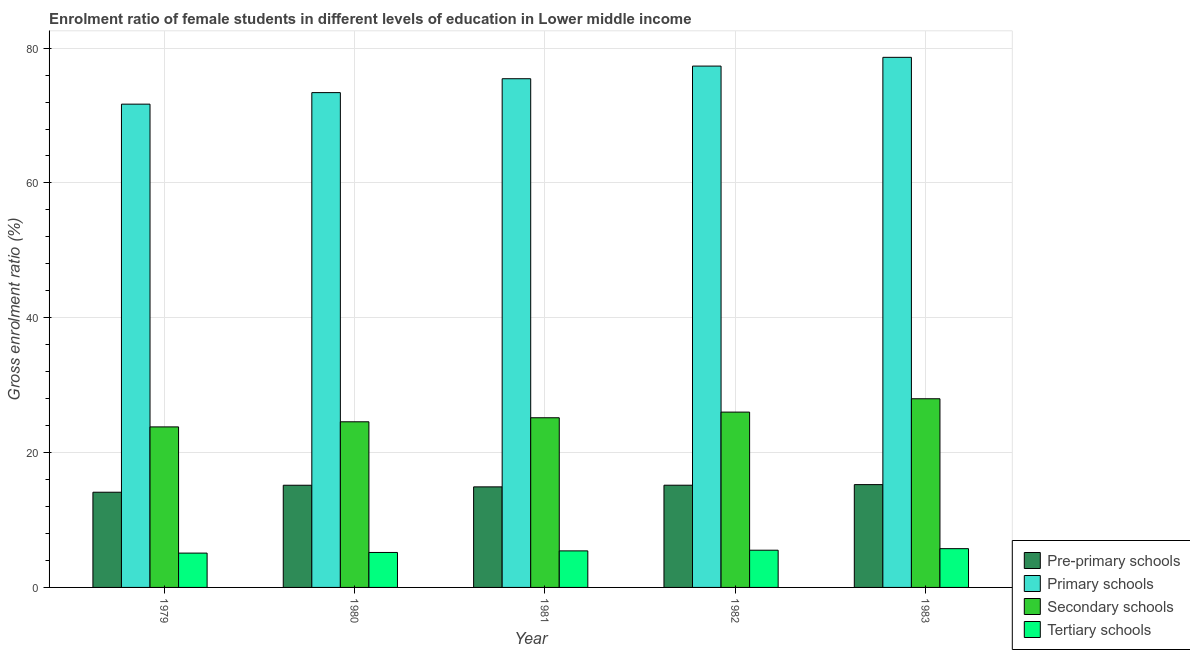Are the number of bars on each tick of the X-axis equal?
Offer a very short reply. Yes. How many bars are there on the 1st tick from the left?
Give a very brief answer. 4. How many bars are there on the 5th tick from the right?
Your answer should be very brief. 4. What is the label of the 1st group of bars from the left?
Give a very brief answer. 1979. What is the gross enrolment ratio(male) in tertiary schools in 1981?
Provide a short and direct response. 5.42. Across all years, what is the maximum gross enrolment ratio(male) in pre-primary schools?
Offer a terse response. 15.25. Across all years, what is the minimum gross enrolment ratio(male) in tertiary schools?
Ensure brevity in your answer.  5.09. In which year was the gross enrolment ratio(male) in pre-primary schools minimum?
Give a very brief answer. 1979. What is the total gross enrolment ratio(male) in pre-primary schools in the graph?
Keep it short and to the point. 74.61. What is the difference between the gross enrolment ratio(male) in pre-primary schools in 1979 and that in 1982?
Make the answer very short. -1.04. What is the difference between the gross enrolment ratio(male) in pre-primary schools in 1979 and the gross enrolment ratio(male) in tertiary schools in 1981?
Your answer should be compact. -0.79. What is the average gross enrolment ratio(male) in secondary schools per year?
Provide a succinct answer. 25.51. In how many years, is the gross enrolment ratio(male) in secondary schools greater than 56 %?
Keep it short and to the point. 0. What is the ratio of the gross enrolment ratio(male) in primary schools in 1980 to that in 1983?
Give a very brief answer. 0.93. Is the gross enrolment ratio(male) in tertiary schools in 1982 less than that in 1983?
Offer a terse response. Yes. Is the difference between the gross enrolment ratio(male) in primary schools in 1981 and 1982 greater than the difference between the gross enrolment ratio(male) in pre-primary schools in 1981 and 1982?
Your response must be concise. No. What is the difference between the highest and the second highest gross enrolment ratio(male) in primary schools?
Provide a succinct answer. 1.3. What is the difference between the highest and the lowest gross enrolment ratio(male) in primary schools?
Offer a very short reply. 6.94. In how many years, is the gross enrolment ratio(male) in pre-primary schools greater than the average gross enrolment ratio(male) in pre-primary schools taken over all years?
Keep it short and to the point. 3. What does the 4th bar from the left in 1979 represents?
Your response must be concise. Tertiary schools. What does the 2nd bar from the right in 1981 represents?
Provide a short and direct response. Secondary schools. How many bars are there?
Offer a very short reply. 20. Are all the bars in the graph horizontal?
Provide a short and direct response. No. What is the difference between two consecutive major ticks on the Y-axis?
Offer a very short reply. 20. Does the graph contain grids?
Your response must be concise. Yes. How many legend labels are there?
Offer a terse response. 4. What is the title of the graph?
Offer a terse response. Enrolment ratio of female students in different levels of education in Lower middle income. Does "Financial sector" appear as one of the legend labels in the graph?
Your answer should be compact. No. What is the label or title of the X-axis?
Your answer should be compact. Year. What is the label or title of the Y-axis?
Your answer should be compact. Gross enrolment ratio (%). What is the Gross enrolment ratio (%) of Pre-primary schools in 1979?
Your response must be concise. 14.12. What is the Gross enrolment ratio (%) in Primary schools in 1979?
Offer a terse response. 71.69. What is the Gross enrolment ratio (%) of Secondary schools in 1979?
Provide a short and direct response. 23.81. What is the Gross enrolment ratio (%) of Tertiary schools in 1979?
Give a very brief answer. 5.09. What is the Gross enrolment ratio (%) in Pre-primary schools in 1980?
Keep it short and to the point. 15.16. What is the Gross enrolment ratio (%) in Primary schools in 1980?
Your answer should be compact. 73.4. What is the Gross enrolment ratio (%) in Secondary schools in 1980?
Provide a short and direct response. 24.57. What is the Gross enrolment ratio (%) in Tertiary schools in 1980?
Offer a very short reply. 5.19. What is the Gross enrolment ratio (%) of Pre-primary schools in 1981?
Keep it short and to the point. 14.92. What is the Gross enrolment ratio (%) in Primary schools in 1981?
Provide a succinct answer. 75.46. What is the Gross enrolment ratio (%) in Secondary schools in 1981?
Keep it short and to the point. 25.17. What is the Gross enrolment ratio (%) of Tertiary schools in 1981?
Your response must be concise. 5.42. What is the Gross enrolment ratio (%) of Pre-primary schools in 1982?
Ensure brevity in your answer.  15.16. What is the Gross enrolment ratio (%) in Primary schools in 1982?
Keep it short and to the point. 77.34. What is the Gross enrolment ratio (%) in Secondary schools in 1982?
Give a very brief answer. 26.01. What is the Gross enrolment ratio (%) in Tertiary schools in 1982?
Your answer should be very brief. 5.52. What is the Gross enrolment ratio (%) in Pre-primary schools in 1983?
Make the answer very short. 15.25. What is the Gross enrolment ratio (%) in Primary schools in 1983?
Ensure brevity in your answer.  78.63. What is the Gross enrolment ratio (%) in Secondary schools in 1983?
Your answer should be compact. 27.99. What is the Gross enrolment ratio (%) in Tertiary schools in 1983?
Offer a terse response. 5.75. Across all years, what is the maximum Gross enrolment ratio (%) in Pre-primary schools?
Provide a short and direct response. 15.25. Across all years, what is the maximum Gross enrolment ratio (%) of Primary schools?
Your response must be concise. 78.63. Across all years, what is the maximum Gross enrolment ratio (%) of Secondary schools?
Make the answer very short. 27.99. Across all years, what is the maximum Gross enrolment ratio (%) in Tertiary schools?
Ensure brevity in your answer.  5.75. Across all years, what is the minimum Gross enrolment ratio (%) in Pre-primary schools?
Ensure brevity in your answer.  14.12. Across all years, what is the minimum Gross enrolment ratio (%) in Primary schools?
Ensure brevity in your answer.  71.69. Across all years, what is the minimum Gross enrolment ratio (%) in Secondary schools?
Ensure brevity in your answer.  23.81. Across all years, what is the minimum Gross enrolment ratio (%) in Tertiary schools?
Your response must be concise. 5.09. What is the total Gross enrolment ratio (%) of Pre-primary schools in the graph?
Give a very brief answer. 74.61. What is the total Gross enrolment ratio (%) of Primary schools in the graph?
Make the answer very short. 376.52. What is the total Gross enrolment ratio (%) in Secondary schools in the graph?
Offer a very short reply. 127.55. What is the total Gross enrolment ratio (%) of Tertiary schools in the graph?
Keep it short and to the point. 26.97. What is the difference between the Gross enrolment ratio (%) of Pre-primary schools in 1979 and that in 1980?
Give a very brief answer. -1.04. What is the difference between the Gross enrolment ratio (%) of Primary schools in 1979 and that in 1980?
Offer a terse response. -1.71. What is the difference between the Gross enrolment ratio (%) in Secondary schools in 1979 and that in 1980?
Ensure brevity in your answer.  -0.76. What is the difference between the Gross enrolment ratio (%) in Tertiary schools in 1979 and that in 1980?
Provide a succinct answer. -0.1. What is the difference between the Gross enrolment ratio (%) in Pre-primary schools in 1979 and that in 1981?
Make the answer very short. -0.79. What is the difference between the Gross enrolment ratio (%) in Primary schools in 1979 and that in 1981?
Offer a terse response. -3.77. What is the difference between the Gross enrolment ratio (%) in Secondary schools in 1979 and that in 1981?
Your answer should be very brief. -1.35. What is the difference between the Gross enrolment ratio (%) of Tertiary schools in 1979 and that in 1981?
Keep it short and to the point. -0.33. What is the difference between the Gross enrolment ratio (%) in Pre-primary schools in 1979 and that in 1982?
Your answer should be compact. -1.04. What is the difference between the Gross enrolment ratio (%) of Primary schools in 1979 and that in 1982?
Keep it short and to the point. -5.65. What is the difference between the Gross enrolment ratio (%) of Secondary schools in 1979 and that in 1982?
Ensure brevity in your answer.  -2.19. What is the difference between the Gross enrolment ratio (%) in Tertiary schools in 1979 and that in 1982?
Your answer should be compact. -0.43. What is the difference between the Gross enrolment ratio (%) in Pre-primary schools in 1979 and that in 1983?
Your answer should be very brief. -1.13. What is the difference between the Gross enrolment ratio (%) of Primary schools in 1979 and that in 1983?
Provide a short and direct response. -6.94. What is the difference between the Gross enrolment ratio (%) in Secondary schools in 1979 and that in 1983?
Your answer should be very brief. -4.17. What is the difference between the Gross enrolment ratio (%) of Tertiary schools in 1979 and that in 1983?
Make the answer very short. -0.66. What is the difference between the Gross enrolment ratio (%) of Pre-primary schools in 1980 and that in 1981?
Your answer should be compact. 0.24. What is the difference between the Gross enrolment ratio (%) of Primary schools in 1980 and that in 1981?
Offer a terse response. -2.06. What is the difference between the Gross enrolment ratio (%) of Secondary schools in 1980 and that in 1981?
Your response must be concise. -0.6. What is the difference between the Gross enrolment ratio (%) in Tertiary schools in 1980 and that in 1981?
Offer a terse response. -0.23. What is the difference between the Gross enrolment ratio (%) of Pre-primary schools in 1980 and that in 1982?
Your answer should be compact. -0. What is the difference between the Gross enrolment ratio (%) of Primary schools in 1980 and that in 1982?
Provide a short and direct response. -3.94. What is the difference between the Gross enrolment ratio (%) of Secondary schools in 1980 and that in 1982?
Your response must be concise. -1.44. What is the difference between the Gross enrolment ratio (%) in Tertiary schools in 1980 and that in 1982?
Provide a short and direct response. -0.33. What is the difference between the Gross enrolment ratio (%) in Pre-primary schools in 1980 and that in 1983?
Provide a short and direct response. -0.09. What is the difference between the Gross enrolment ratio (%) of Primary schools in 1980 and that in 1983?
Provide a short and direct response. -5.23. What is the difference between the Gross enrolment ratio (%) of Secondary schools in 1980 and that in 1983?
Offer a terse response. -3.42. What is the difference between the Gross enrolment ratio (%) of Tertiary schools in 1980 and that in 1983?
Give a very brief answer. -0.56. What is the difference between the Gross enrolment ratio (%) in Pre-primary schools in 1981 and that in 1982?
Your response must be concise. -0.25. What is the difference between the Gross enrolment ratio (%) in Primary schools in 1981 and that in 1982?
Give a very brief answer. -1.88. What is the difference between the Gross enrolment ratio (%) in Secondary schools in 1981 and that in 1982?
Offer a terse response. -0.84. What is the difference between the Gross enrolment ratio (%) in Tertiary schools in 1981 and that in 1982?
Give a very brief answer. -0.1. What is the difference between the Gross enrolment ratio (%) of Pre-primary schools in 1981 and that in 1983?
Offer a very short reply. -0.33. What is the difference between the Gross enrolment ratio (%) of Primary schools in 1981 and that in 1983?
Make the answer very short. -3.17. What is the difference between the Gross enrolment ratio (%) in Secondary schools in 1981 and that in 1983?
Keep it short and to the point. -2.82. What is the difference between the Gross enrolment ratio (%) in Tertiary schools in 1981 and that in 1983?
Keep it short and to the point. -0.33. What is the difference between the Gross enrolment ratio (%) of Pre-primary schools in 1982 and that in 1983?
Provide a succinct answer. -0.09. What is the difference between the Gross enrolment ratio (%) of Primary schools in 1982 and that in 1983?
Ensure brevity in your answer.  -1.3. What is the difference between the Gross enrolment ratio (%) in Secondary schools in 1982 and that in 1983?
Keep it short and to the point. -1.98. What is the difference between the Gross enrolment ratio (%) of Tertiary schools in 1982 and that in 1983?
Offer a terse response. -0.23. What is the difference between the Gross enrolment ratio (%) of Pre-primary schools in 1979 and the Gross enrolment ratio (%) of Primary schools in 1980?
Provide a short and direct response. -59.28. What is the difference between the Gross enrolment ratio (%) of Pre-primary schools in 1979 and the Gross enrolment ratio (%) of Secondary schools in 1980?
Your answer should be compact. -10.45. What is the difference between the Gross enrolment ratio (%) of Pre-primary schools in 1979 and the Gross enrolment ratio (%) of Tertiary schools in 1980?
Provide a succinct answer. 8.94. What is the difference between the Gross enrolment ratio (%) in Primary schools in 1979 and the Gross enrolment ratio (%) in Secondary schools in 1980?
Keep it short and to the point. 47.12. What is the difference between the Gross enrolment ratio (%) in Primary schools in 1979 and the Gross enrolment ratio (%) in Tertiary schools in 1980?
Provide a succinct answer. 66.5. What is the difference between the Gross enrolment ratio (%) of Secondary schools in 1979 and the Gross enrolment ratio (%) of Tertiary schools in 1980?
Ensure brevity in your answer.  18.63. What is the difference between the Gross enrolment ratio (%) in Pre-primary schools in 1979 and the Gross enrolment ratio (%) in Primary schools in 1981?
Your response must be concise. -61.34. What is the difference between the Gross enrolment ratio (%) in Pre-primary schools in 1979 and the Gross enrolment ratio (%) in Secondary schools in 1981?
Your response must be concise. -11.04. What is the difference between the Gross enrolment ratio (%) in Pre-primary schools in 1979 and the Gross enrolment ratio (%) in Tertiary schools in 1981?
Provide a short and direct response. 8.7. What is the difference between the Gross enrolment ratio (%) in Primary schools in 1979 and the Gross enrolment ratio (%) in Secondary schools in 1981?
Provide a succinct answer. 46.52. What is the difference between the Gross enrolment ratio (%) of Primary schools in 1979 and the Gross enrolment ratio (%) of Tertiary schools in 1981?
Your answer should be very brief. 66.27. What is the difference between the Gross enrolment ratio (%) in Secondary schools in 1979 and the Gross enrolment ratio (%) in Tertiary schools in 1981?
Offer a terse response. 18.39. What is the difference between the Gross enrolment ratio (%) in Pre-primary schools in 1979 and the Gross enrolment ratio (%) in Primary schools in 1982?
Offer a terse response. -63.21. What is the difference between the Gross enrolment ratio (%) of Pre-primary schools in 1979 and the Gross enrolment ratio (%) of Secondary schools in 1982?
Keep it short and to the point. -11.88. What is the difference between the Gross enrolment ratio (%) of Pre-primary schools in 1979 and the Gross enrolment ratio (%) of Tertiary schools in 1982?
Provide a succinct answer. 8.6. What is the difference between the Gross enrolment ratio (%) of Primary schools in 1979 and the Gross enrolment ratio (%) of Secondary schools in 1982?
Keep it short and to the point. 45.68. What is the difference between the Gross enrolment ratio (%) in Primary schools in 1979 and the Gross enrolment ratio (%) in Tertiary schools in 1982?
Offer a terse response. 66.17. What is the difference between the Gross enrolment ratio (%) of Secondary schools in 1979 and the Gross enrolment ratio (%) of Tertiary schools in 1982?
Your answer should be very brief. 18.29. What is the difference between the Gross enrolment ratio (%) in Pre-primary schools in 1979 and the Gross enrolment ratio (%) in Primary schools in 1983?
Make the answer very short. -64.51. What is the difference between the Gross enrolment ratio (%) of Pre-primary schools in 1979 and the Gross enrolment ratio (%) of Secondary schools in 1983?
Offer a very short reply. -13.86. What is the difference between the Gross enrolment ratio (%) of Pre-primary schools in 1979 and the Gross enrolment ratio (%) of Tertiary schools in 1983?
Give a very brief answer. 8.37. What is the difference between the Gross enrolment ratio (%) in Primary schools in 1979 and the Gross enrolment ratio (%) in Secondary schools in 1983?
Provide a succinct answer. 43.7. What is the difference between the Gross enrolment ratio (%) in Primary schools in 1979 and the Gross enrolment ratio (%) in Tertiary schools in 1983?
Provide a short and direct response. 65.94. What is the difference between the Gross enrolment ratio (%) in Secondary schools in 1979 and the Gross enrolment ratio (%) in Tertiary schools in 1983?
Provide a succinct answer. 18.06. What is the difference between the Gross enrolment ratio (%) in Pre-primary schools in 1980 and the Gross enrolment ratio (%) in Primary schools in 1981?
Your response must be concise. -60.3. What is the difference between the Gross enrolment ratio (%) in Pre-primary schools in 1980 and the Gross enrolment ratio (%) in Secondary schools in 1981?
Ensure brevity in your answer.  -10.01. What is the difference between the Gross enrolment ratio (%) in Pre-primary schools in 1980 and the Gross enrolment ratio (%) in Tertiary schools in 1981?
Your response must be concise. 9.74. What is the difference between the Gross enrolment ratio (%) in Primary schools in 1980 and the Gross enrolment ratio (%) in Secondary schools in 1981?
Your answer should be compact. 48.23. What is the difference between the Gross enrolment ratio (%) of Primary schools in 1980 and the Gross enrolment ratio (%) of Tertiary schools in 1981?
Ensure brevity in your answer.  67.98. What is the difference between the Gross enrolment ratio (%) in Secondary schools in 1980 and the Gross enrolment ratio (%) in Tertiary schools in 1981?
Make the answer very short. 19.15. What is the difference between the Gross enrolment ratio (%) in Pre-primary schools in 1980 and the Gross enrolment ratio (%) in Primary schools in 1982?
Keep it short and to the point. -62.18. What is the difference between the Gross enrolment ratio (%) of Pre-primary schools in 1980 and the Gross enrolment ratio (%) of Secondary schools in 1982?
Your answer should be compact. -10.85. What is the difference between the Gross enrolment ratio (%) in Pre-primary schools in 1980 and the Gross enrolment ratio (%) in Tertiary schools in 1982?
Your response must be concise. 9.64. What is the difference between the Gross enrolment ratio (%) of Primary schools in 1980 and the Gross enrolment ratio (%) of Secondary schools in 1982?
Your answer should be very brief. 47.39. What is the difference between the Gross enrolment ratio (%) of Primary schools in 1980 and the Gross enrolment ratio (%) of Tertiary schools in 1982?
Provide a short and direct response. 67.88. What is the difference between the Gross enrolment ratio (%) in Secondary schools in 1980 and the Gross enrolment ratio (%) in Tertiary schools in 1982?
Keep it short and to the point. 19.05. What is the difference between the Gross enrolment ratio (%) of Pre-primary schools in 1980 and the Gross enrolment ratio (%) of Primary schools in 1983?
Make the answer very short. -63.48. What is the difference between the Gross enrolment ratio (%) of Pre-primary schools in 1980 and the Gross enrolment ratio (%) of Secondary schools in 1983?
Provide a short and direct response. -12.83. What is the difference between the Gross enrolment ratio (%) in Pre-primary schools in 1980 and the Gross enrolment ratio (%) in Tertiary schools in 1983?
Give a very brief answer. 9.41. What is the difference between the Gross enrolment ratio (%) of Primary schools in 1980 and the Gross enrolment ratio (%) of Secondary schools in 1983?
Offer a very short reply. 45.41. What is the difference between the Gross enrolment ratio (%) of Primary schools in 1980 and the Gross enrolment ratio (%) of Tertiary schools in 1983?
Make the answer very short. 67.65. What is the difference between the Gross enrolment ratio (%) of Secondary schools in 1980 and the Gross enrolment ratio (%) of Tertiary schools in 1983?
Your response must be concise. 18.82. What is the difference between the Gross enrolment ratio (%) in Pre-primary schools in 1981 and the Gross enrolment ratio (%) in Primary schools in 1982?
Offer a terse response. -62.42. What is the difference between the Gross enrolment ratio (%) in Pre-primary schools in 1981 and the Gross enrolment ratio (%) in Secondary schools in 1982?
Provide a succinct answer. -11.09. What is the difference between the Gross enrolment ratio (%) in Pre-primary schools in 1981 and the Gross enrolment ratio (%) in Tertiary schools in 1982?
Your response must be concise. 9.4. What is the difference between the Gross enrolment ratio (%) of Primary schools in 1981 and the Gross enrolment ratio (%) of Secondary schools in 1982?
Make the answer very short. 49.45. What is the difference between the Gross enrolment ratio (%) in Primary schools in 1981 and the Gross enrolment ratio (%) in Tertiary schools in 1982?
Your answer should be very brief. 69.94. What is the difference between the Gross enrolment ratio (%) of Secondary schools in 1981 and the Gross enrolment ratio (%) of Tertiary schools in 1982?
Keep it short and to the point. 19.65. What is the difference between the Gross enrolment ratio (%) in Pre-primary schools in 1981 and the Gross enrolment ratio (%) in Primary schools in 1983?
Make the answer very short. -63.72. What is the difference between the Gross enrolment ratio (%) in Pre-primary schools in 1981 and the Gross enrolment ratio (%) in Secondary schools in 1983?
Make the answer very short. -13.07. What is the difference between the Gross enrolment ratio (%) of Pre-primary schools in 1981 and the Gross enrolment ratio (%) of Tertiary schools in 1983?
Provide a short and direct response. 9.17. What is the difference between the Gross enrolment ratio (%) in Primary schools in 1981 and the Gross enrolment ratio (%) in Secondary schools in 1983?
Keep it short and to the point. 47.47. What is the difference between the Gross enrolment ratio (%) of Primary schools in 1981 and the Gross enrolment ratio (%) of Tertiary schools in 1983?
Make the answer very short. 69.71. What is the difference between the Gross enrolment ratio (%) in Secondary schools in 1981 and the Gross enrolment ratio (%) in Tertiary schools in 1983?
Provide a short and direct response. 19.42. What is the difference between the Gross enrolment ratio (%) in Pre-primary schools in 1982 and the Gross enrolment ratio (%) in Primary schools in 1983?
Offer a terse response. -63.47. What is the difference between the Gross enrolment ratio (%) in Pre-primary schools in 1982 and the Gross enrolment ratio (%) in Secondary schools in 1983?
Keep it short and to the point. -12.82. What is the difference between the Gross enrolment ratio (%) in Pre-primary schools in 1982 and the Gross enrolment ratio (%) in Tertiary schools in 1983?
Make the answer very short. 9.41. What is the difference between the Gross enrolment ratio (%) of Primary schools in 1982 and the Gross enrolment ratio (%) of Secondary schools in 1983?
Your answer should be compact. 49.35. What is the difference between the Gross enrolment ratio (%) of Primary schools in 1982 and the Gross enrolment ratio (%) of Tertiary schools in 1983?
Provide a succinct answer. 71.58. What is the difference between the Gross enrolment ratio (%) of Secondary schools in 1982 and the Gross enrolment ratio (%) of Tertiary schools in 1983?
Provide a succinct answer. 20.26. What is the average Gross enrolment ratio (%) of Pre-primary schools per year?
Your response must be concise. 14.92. What is the average Gross enrolment ratio (%) of Primary schools per year?
Your answer should be compact. 75.3. What is the average Gross enrolment ratio (%) in Secondary schools per year?
Provide a succinct answer. 25.51. What is the average Gross enrolment ratio (%) of Tertiary schools per year?
Your answer should be very brief. 5.39. In the year 1979, what is the difference between the Gross enrolment ratio (%) in Pre-primary schools and Gross enrolment ratio (%) in Primary schools?
Ensure brevity in your answer.  -57.57. In the year 1979, what is the difference between the Gross enrolment ratio (%) in Pre-primary schools and Gross enrolment ratio (%) in Secondary schools?
Your answer should be very brief. -9.69. In the year 1979, what is the difference between the Gross enrolment ratio (%) of Pre-primary schools and Gross enrolment ratio (%) of Tertiary schools?
Your answer should be compact. 9.03. In the year 1979, what is the difference between the Gross enrolment ratio (%) in Primary schools and Gross enrolment ratio (%) in Secondary schools?
Offer a terse response. 47.88. In the year 1979, what is the difference between the Gross enrolment ratio (%) of Primary schools and Gross enrolment ratio (%) of Tertiary schools?
Provide a succinct answer. 66.6. In the year 1979, what is the difference between the Gross enrolment ratio (%) of Secondary schools and Gross enrolment ratio (%) of Tertiary schools?
Your answer should be compact. 18.72. In the year 1980, what is the difference between the Gross enrolment ratio (%) in Pre-primary schools and Gross enrolment ratio (%) in Primary schools?
Keep it short and to the point. -58.24. In the year 1980, what is the difference between the Gross enrolment ratio (%) in Pre-primary schools and Gross enrolment ratio (%) in Secondary schools?
Give a very brief answer. -9.41. In the year 1980, what is the difference between the Gross enrolment ratio (%) of Pre-primary schools and Gross enrolment ratio (%) of Tertiary schools?
Your answer should be very brief. 9.97. In the year 1980, what is the difference between the Gross enrolment ratio (%) of Primary schools and Gross enrolment ratio (%) of Secondary schools?
Offer a terse response. 48.83. In the year 1980, what is the difference between the Gross enrolment ratio (%) in Primary schools and Gross enrolment ratio (%) in Tertiary schools?
Your response must be concise. 68.21. In the year 1980, what is the difference between the Gross enrolment ratio (%) of Secondary schools and Gross enrolment ratio (%) of Tertiary schools?
Give a very brief answer. 19.38. In the year 1981, what is the difference between the Gross enrolment ratio (%) in Pre-primary schools and Gross enrolment ratio (%) in Primary schools?
Your response must be concise. -60.54. In the year 1981, what is the difference between the Gross enrolment ratio (%) of Pre-primary schools and Gross enrolment ratio (%) of Secondary schools?
Your answer should be very brief. -10.25. In the year 1981, what is the difference between the Gross enrolment ratio (%) of Pre-primary schools and Gross enrolment ratio (%) of Tertiary schools?
Your answer should be compact. 9.5. In the year 1981, what is the difference between the Gross enrolment ratio (%) of Primary schools and Gross enrolment ratio (%) of Secondary schools?
Your response must be concise. 50.29. In the year 1981, what is the difference between the Gross enrolment ratio (%) of Primary schools and Gross enrolment ratio (%) of Tertiary schools?
Offer a very short reply. 70.04. In the year 1981, what is the difference between the Gross enrolment ratio (%) in Secondary schools and Gross enrolment ratio (%) in Tertiary schools?
Your answer should be compact. 19.75. In the year 1982, what is the difference between the Gross enrolment ratio (%) of Pre-primary schools and Gross enrolment ratio (%) of Primary schools?
Your response must be concise. -62.17. In the year 1982, what is the difference between the Gross enrolment ratio (%) in Pre-primary schools and Gross enrolment ratio (%) in Secondary schools?
Your answer should be very brief. -10.84. In the year 1982, what is the difference between the Gross enrolment ratio (%) of Pre-primary schools and Gross enrolment ratio (%) of Tertiary schools?
Offer a terse response. 9.64. In the year 1982, what is the difference between the Gross enrolment ratio (%) in Primary schools and Gross enrolment ratio (%) in Secondary schools?
Offer a very short reply. 51.33. In the year 1982, what is the difference between the Gross enrolment ratio (%) of Primary schools and Gross enrolment ratio (%) of Tertiary schools?
Provide a short and direct response. 71.81. In the year 1982, what is the difference between the Gross enrolment ratio (%) of Secondary schools and Gross enrolment ratio (%) of Tertiary schools?
Provide a short and direct response. 20.49. In the year 1983, what is the difference between the Gross enrolment ratio (%) of Pre-primary schools and Gross enrolment ratio (%) of Primary schools?
Your answer should be compact. -63.38. In the year 1983, what is the difference between the Gross enrolment ratio (%) of Pre-primary schools and Gross enrolment ratio (%) of Secondary schools?
Offer a terse response. -12.74. In the year 1983, what is the difference between the Gross enrolment ratio (%) of Pre-primary schools and Gross enrolment ratio (%) of Tertiary schools?
Give a very brief answer. 9.5. In the year 1983, what is the difference between the Gross enrolment ratio (%) in Primary schools and Gross enrolment ratio (%) in Secondary schools?
Offer a terse response. 50.65. In the year 1983, what is the difference between the Gross enrolment ratio (%) in Primary schools and Gross enrolment ratio (%) in Tertiary schools?
Your answer should be compact. 72.88. In the year 1983, what is the difference between the Gross enrolment ratio (%) in Secondary schools and Gross enrolment ratio (%) in Tertiary schools?
Your answer should be compact. 22.24. What is the ratio of the Gross enrolment ratio (%) of Pre-primary schools in 1979 to that in 1980?
Make the answer very short. 0.93. What is the ratio of the Gross enrolment ratio (%) of Primary schools in 1979 to that in 1980?
Your answer should be very brief. 0.98. What is the ratio of the Gross enrolment ratio (%) of Secondary schools in 1979 to that in 1980?
Your answer should be compact. 0.97. What is the ratio of the Gross enrolment ratio (%) of Tertiary schools in 1979 to that in 1980?
Provide a succinct answer. 0.98. What is the ratio of the Gross enrolment ratio (%) in Pre-primary schools in 1979 to that in 1981?
Give a very brief answer. 0.95. What is the ratio of the Gross enrolment ratio (%) in Primary schools in 1979 to that in 1981?
Keep it short and to the point. 0.95. What is the ratio of the Gross enrolment ratio (%) of Secondary schools in 1979 to that in 1981?
Provide a succinct answer. 0.95. What is the ratio of the Gross enrolment ratio (%) in Tertiary schools in 1979 to that in 1981?
Give a very brief answer. 0.94. What is the ratio of the Gross enrolment ratio (%) of Pre-primary schools in 1979 to that in 1982?
Keep it short and to the point. 0.93. What is the ratio of the Gross enrolment ratio (%) of Primary schools in 1979 to that in 1982?
Keep it short and to the point. 0.93. What is the ratio of the Gross enrolment ratio (%) in Secondary schools in 1979 to that in 1982?
Give a very brief answer. 0.92. What is the ratio of the Gross enrolment ratio (%) of Tertiary schools in 1979 to that in 1982?
Your response must be concise. 0.92. What is the ratio of the Gross enrolment ratio (%) of Pre-primary schools in 1979 to that in 1983?
Your response must be concise. 0.93. What is the ratio of the Gross enrolment ratio (%) of Primary schools in 1979 to that in 1983?
Give a very brief answer. 0.91. What is the ratio of the Gross enrolment ratio (%) of Secondary schools in 1979 to that in 1983?
Give a very brief answer. 0.85. What is the ratio of the Gross enrolment ratio (%) of Tertiary schools in 1979 to that in 1983?
Offer a terse response. 0.89. What is the ratio of the Gross enrolment ratio (%) of Pre-primary schools in 1980 to that in 1981?
Your response must be concise. 1.02. What is the ratio of the Gross enrolment ratio (%) of Primary schools in 1980 to that in 1981?
Keep it short and to the point. 0.97. What is the ratio of the Gross enrolment ratio (%) of Secondary schools in 1980 to that in 1981?
Your answer should be compact. 0.98. What is the ratio of the Gross enrolment ratio (%) of Tertiary schools in 1980 to that in 1981?
Your response must be concise. 0.96. What is the ratio of the Gross enrolment ratio (%) of Pre-primary schools in 1980 to that in 1982?
Offer a very short reply. 1. What is the ratio of the Gross enrolment ratio (%) in Primary schools in 1980 to that in 1982?
Your answer should be very brief. 0.95. What is the ratio of the Gross enrolment ratio (%) of Secondary schools in 1980 to that in 1982?
Offer a very short reply. 0.94. What is the ratio of the Gross enrolment ratio (%) of Tertiary schools in 1980 to that in 1982?
Your response must be concise. 0.94. What is the ratio of the Gross enrolment ratio (%) of Pre-primary schools in 1980 to that in 1983?
Your answer should be very brief. 0.99. What is the ratio of the Gross enrolment ratio (%) in Primary schools in 1980 to that in 1983?
Your answer should be compact. 0.93. What is the ratio of the Gross enrolment ratio (%) in Secondary schools in 1980 to that in 1983?
Offer a terse response. 0.88. What is the ratio of the Gross enrolment ratio (%) in Tertiary schools in 1980 to that in 1983?
Make the answer very short. 0.9. What is the ratio of the Gross enrolment ratio (%) in Pre-primary schools in 1981 to that in 1982?
Your answer should be very brief. 0.98. What is the ratio of the Gross enrolment ratio (%) in Primary schools in 1981 to that in 1982?
Give a very brief answer. 0.98. What is the ratio of the Gross enrolment ratio (%) in Secondary schools in 1981 to that in 1982?
Make the answer very short. 0.97. What is the ratio of the Gross enrolment ratio (%) of Tertiary schools in 1981 to that in 1982?
Offer a terse response. 0.98. What is the ratio of the Gross enrolment ratio (%) of Pre-primary schools in 1981 to that in 1983?
Your response must be concise. 0.98. What is the ratio of the Gross enrolment ratio (%) of Primary schools in 1981 to that in 1983?
Provide a succinct answer. 0.96. What is the ratio of the Gross enrolment ratio (%) in Secondary schools in 1981 to that in 1983?
Make the answer very short. 0.9. What is the ratio of the Gross enrolment ratio (%) in Tertiary schools in 1981 to that in 1983?
Your answer should be very brief. 0.94. What is the ratio of the Gross enrolment ratio (%) in Primary schools in 1982 to that in 1983?
Offer a very short reply. 0.98. What is the ratio of the Gross enrolment ratio (%) of Secondary schools in 1982 to that in 1983?
Give a very brief answer. 0.93. What is the ratio of the Gross enrolment ratio (%) in Tertiary schools in 1982 to that in 1983?
Your answer should be very brief. 0.96. What is the difference between the highest and the second highest Gross enrolment ratio (%) in Pre-primary schools?
Your answer should be compact. 0.09. What is the difference between the highest and the second highest Gross enrolment ratio (%) of Primary schools?
Keep it short and to the point. 1.3. What is the difference between the highest and the second highest Gross enrolment ratio (%) of Secondary schools?
Offer a very short reply. 1.98. What is the difference between the highest and the second highest Gross enrolment ratio (%) in Tertiary schools?
Ensure brevity in your answer.  0.23. What is the difference between the highest and the lowest Gross enrolment ratio (%) in Pre-primary schools?
Your response must be concise. 1.13. What is the difference between the highest and the lowest Gross enrolment ratio (%) of Primary schools?
Give a very brief answer. 6.94. What is the difference between the highest and the lowest Gross enrolment ratio (%) of Secondary schools?
Keep it short and to the point. 4.17. What is the difference between the highest and the lowest Gross enrolment ratio (%) in Tertiary schools?
Offer a very short reply. 0.66. 